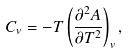Convert formula to latex. <formula><loc_0><loc_0><loc_500><loc_500>C _ { v } = - T \left ( \frac { \partial ^ { 2 } A } { \partial T ^ { 2 } } \right ) _ { v } ,</formula> 